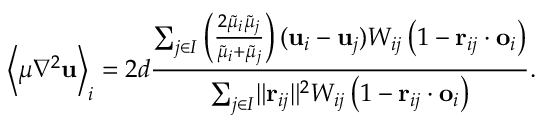<formula> <loc_0><loc_0><loc_500><loc_500>\left < \mu \nabla ^ { 2 } u \right > _ { i } = 2 d \frac { \sum _ { j \in I } \left ( \frac { 2 \widetilde { \mu } _ { i } \widetilde { \mu } _ { j } } { \widetilde { \mu } _ { i } + \widetilde { \mu } _ { j } } \right ) ( u _ { i } - u _ { j } ) W _ { i j } \left ( 1 - r _ { i j } \cdot o _ { i } \right ) } { \sum _ { j \in I } \| r _ { i j } \| ^ { 2 } W _ { i j } \left ( 1 - r _ { i j } \cdot o _ { i } \right ) } .</formula> 